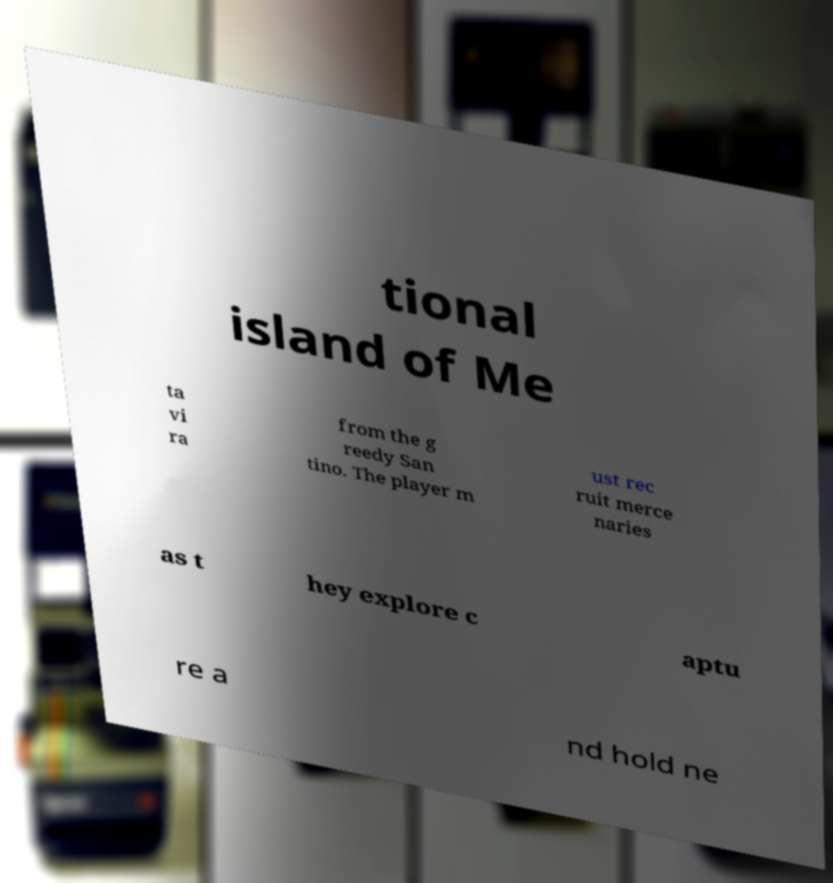Please identify and transcribe the text found in this image. tional island of Me ta vi ra from the g reedy San tino. The player m ust rec ruit merce naries as t hey explore c aptu re a nd hold ne 